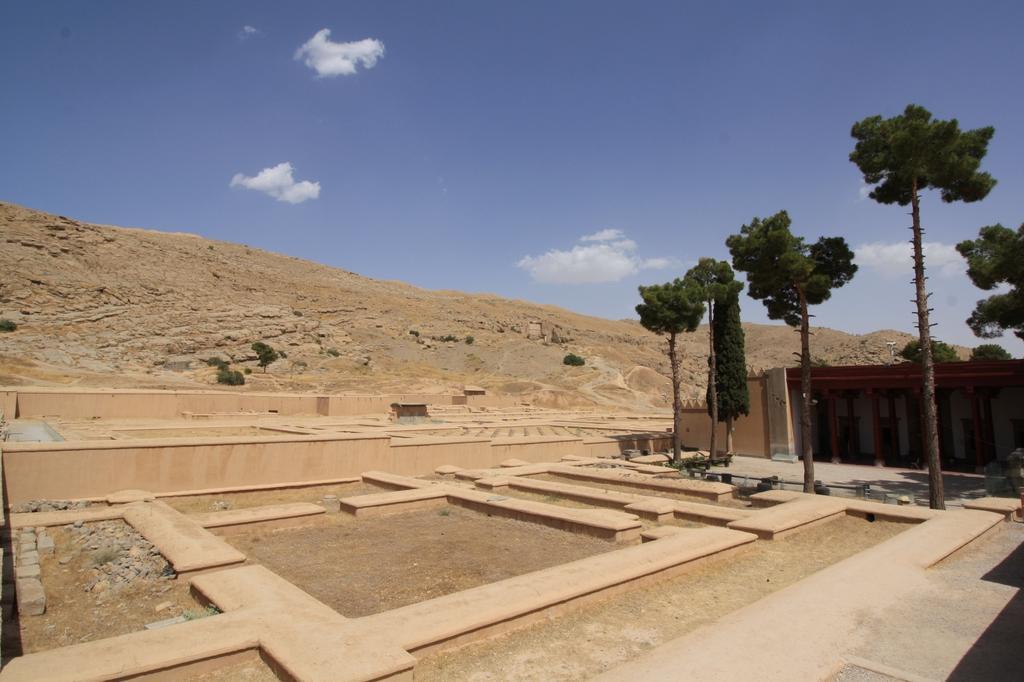Describe this image in one or two sentences. In this image we can see brown color stone foundation. Behind there are some two huge trees. In the background we can see huge mountain. 